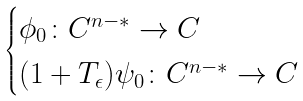<formula> <loc_0><loc_0><loc_500><loc_500>\begin{cases} \phi _ { 0 } \colon C ^ { n - * } \to C \\ ( 1 + T _ { \epsilon } ) \psi _ { 0 } \colon C ^ { n - * } \to C \end{cases}</formula> 